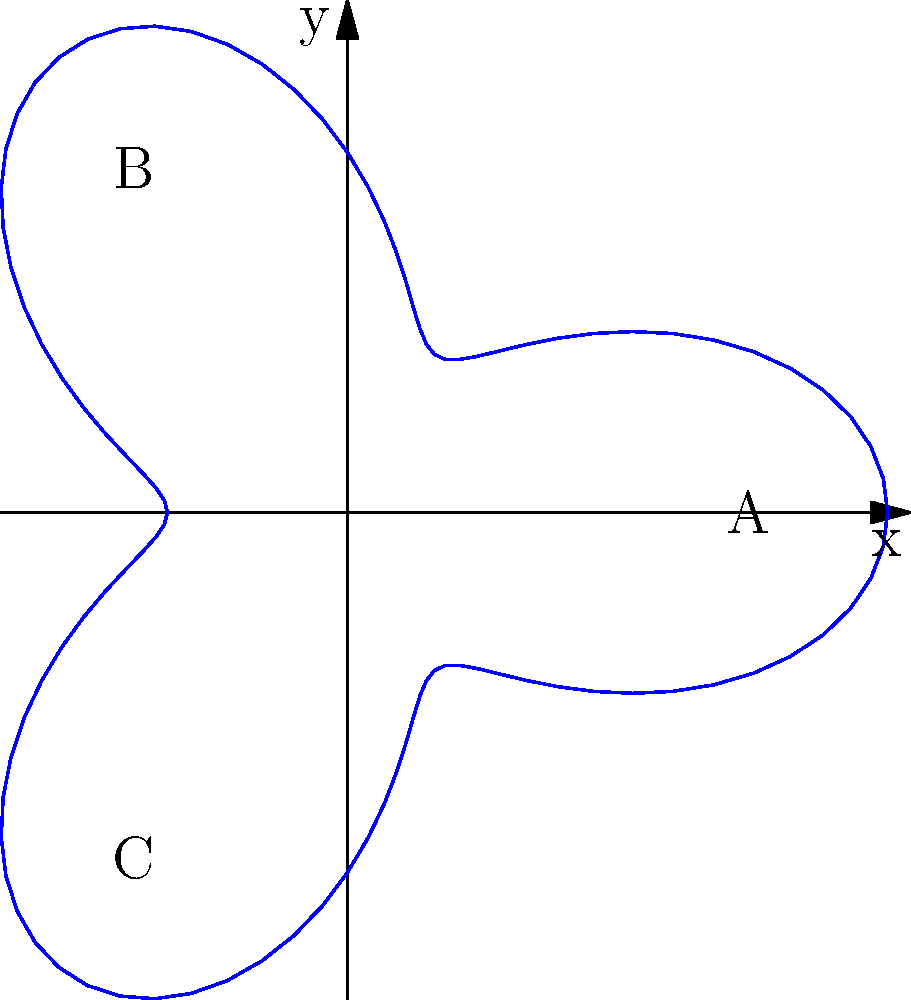As a former executive transitioning to a new career, you've mapped out potential paths using a polar curve represented by the equation $r = 2 + \cos(3\theta)$. Three key milestones in your career transition are represented by points A(2,0), B(-1,√3), and C(-1,-√3) on this curve. If you start at point A and need to pass through either B or C to reach your ultimate career goal, which path would be shorter, and by how much (in radians)? Assume you can only travel along the curve. To solve this problem, we need to calculate the arc lengths from A to B and A to C:

1) First, let's find the angles for points A, B, and C:
   A: $\theta_A = 0$ (given)
   B: $\theta_B = \frac{2\pi}{3}$ (120°)
   C: $\theta_C = \frac{4\pi}{3}$ (240°)

2) The formula for arc length in polar coordinates is:
   $L = \int_{\alpha}^{\beta} \sqrt{r^2 + (\frac{dr}{d\theta})^2} d\theta$

3) For our curve, $r = 2 + \cos(3\theta)$, so $\frac{dr}{d\theta} = -3\sin(3\theta)$

4) Substituting into the arc length formula:
   $L = \int_{\alpha}^{\beta} \sqrt{(2+\cos(3\theta))^2 + (-3\sin(3\theta))^2} d\theta$

5) This integral is complex, so we'll use numerical integration:
   
   Path A to B: $\int_{0}^{\frac{2\pi}{3}} \sqrt{(2+\cos(3\theta))^2 + (-3\sin(3\theta))^2} d\theta \approx 2.8033$
   
   Path A to C: $\int_{0}^{\frac{4\pi}{3}} \sqrt{(2+\cos(3\theta))^2 + (-3\sin(3\theta))^2} d\theta \approx 5.6066$

6) The path from A to B is shorter by approximately 2.8033 radians.
Answer: Path A to B; shorter by 2.8033 radians 